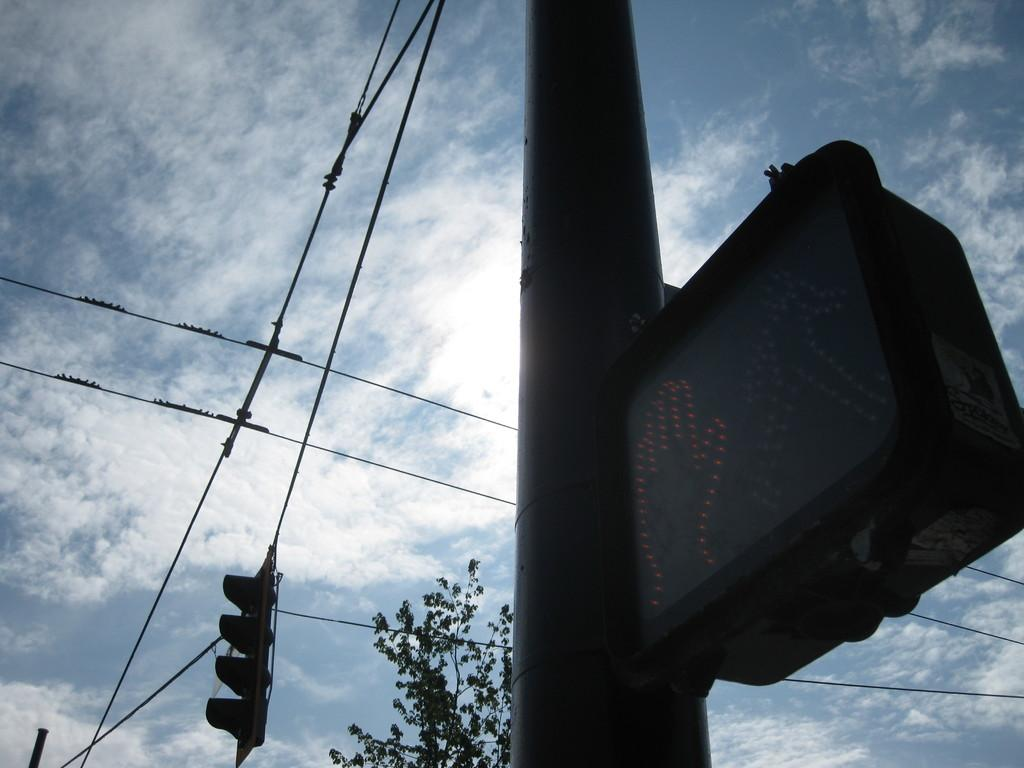What is attached to the pole in the image? There is a display board attached to the pole in the image. What can be seen in the background of the image? There are traffic lights, cables, a tree, and the sky visible in the background of the image. What is the condition of the sky in the image? The sky appears to be cloudy in the image. Where is the lunchroom located in the image? There is no lunchroom present in the image. What type of fire can be seen in the image? There is no fire present in the image. 